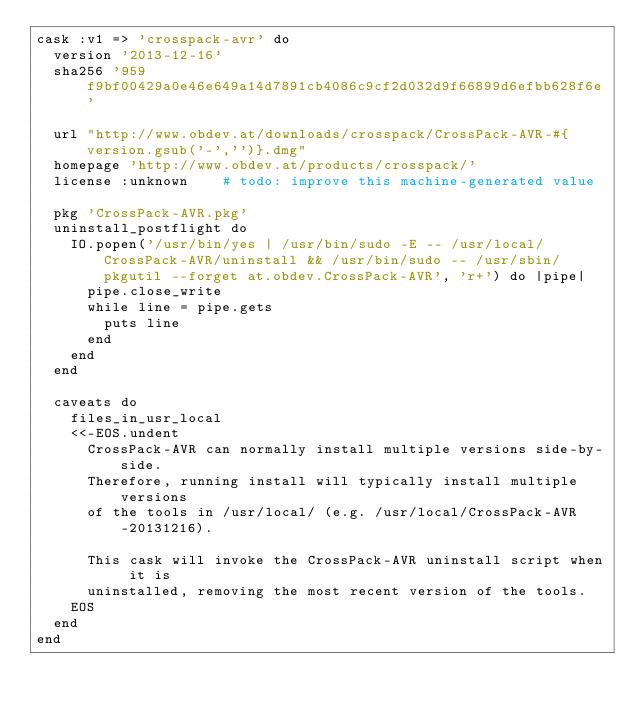<code> <loc_0><loc_0><loc_500><loc_500><_Ruby_>cask :v1 => 'crosspack-avr' do
  version '2013-12-16'
  sha256 '959f9bf00429a0e46e649a14d7891cb4086c9cf2d032d9f66899d6efbb628f6e'

  url "http://www.obdev.at/downloads/crosspack/CrossPack-AVR-#{version.gsub('-','')}.dmg"
  homepage 'http://www.obdev.at/products/crosspack/'
  license :unknown    # todo: improve this machine-generated value

  pkg 'CrossPack-AVR.pkg'
  uninstall_postflight do
    IO.popen('/usr/bin/yes | /usr/bin/sudo -E -- /usr/local/CrossPack-AVR/uninstall && /usr/bin/sudo -- /usr/sbin/pkgutil --forget at.obdev.CrossPack-AVR', 'r+') do |pipe|
      pipe.close_write
      while line = pipe.gets
        puts line
      end
    end
  end

  caveats do
    files_in_usr_local
    <<-EOS.undent
      CrossPack-AVR can normally install multiple versions side-by-side.
      Therefore, running install will typically install multiple versions
      of the tools in /usr/local/ (e.g. /usr/local/CrossPack-AVR-20131216).

      This cask will invoke the CrossPack-AVR uninstall script when it is
      uninstalled, removing the most recent version of the tools.
    EOS
  end
end
</code> 